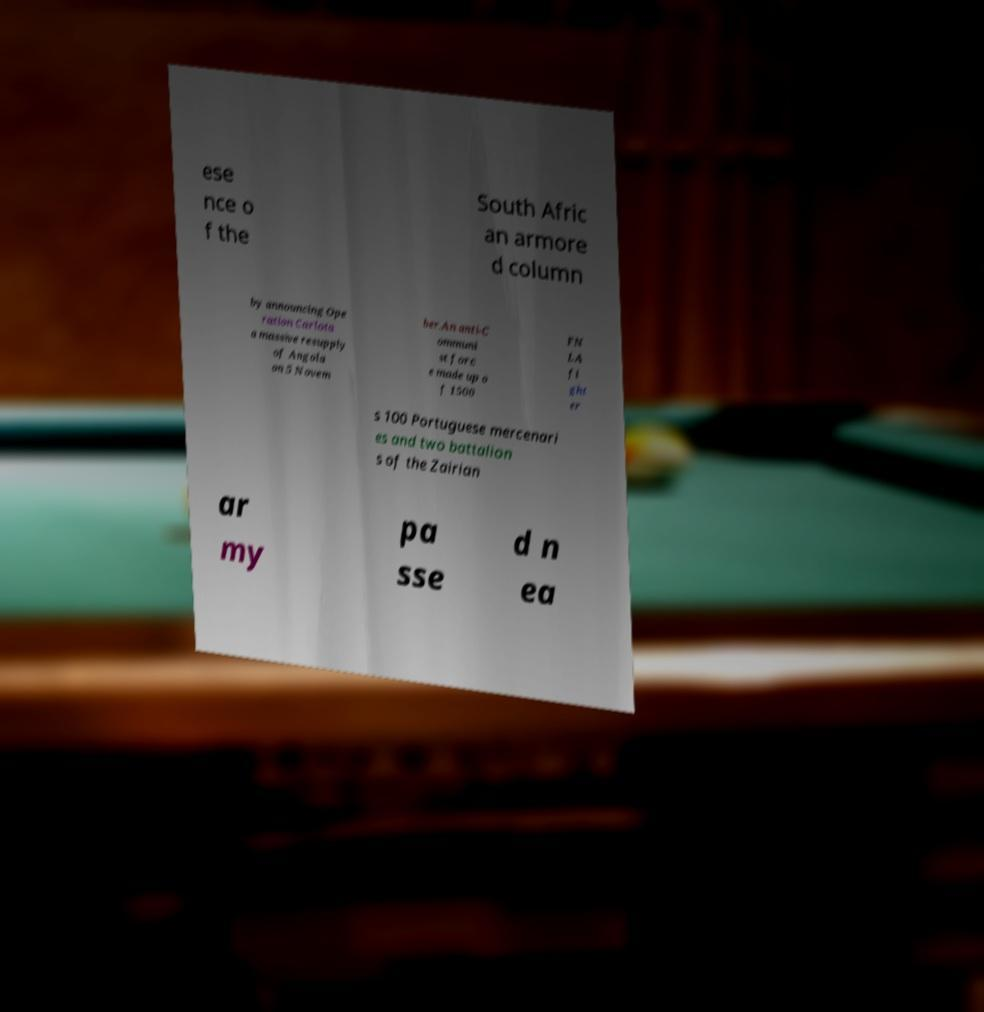Please identify and transcribe the text found in this image. ese nce o f the South Afric an armore d column by announcing Ope ration Carlota a massive resupply of Angola on 5 Novem ber.An anti-C ommuni st forc e made up o f 1500 FN LA fi ght er s 100 Portuguese mercenari es and two battalion s of the Zairian ar my pa sse d n ea 